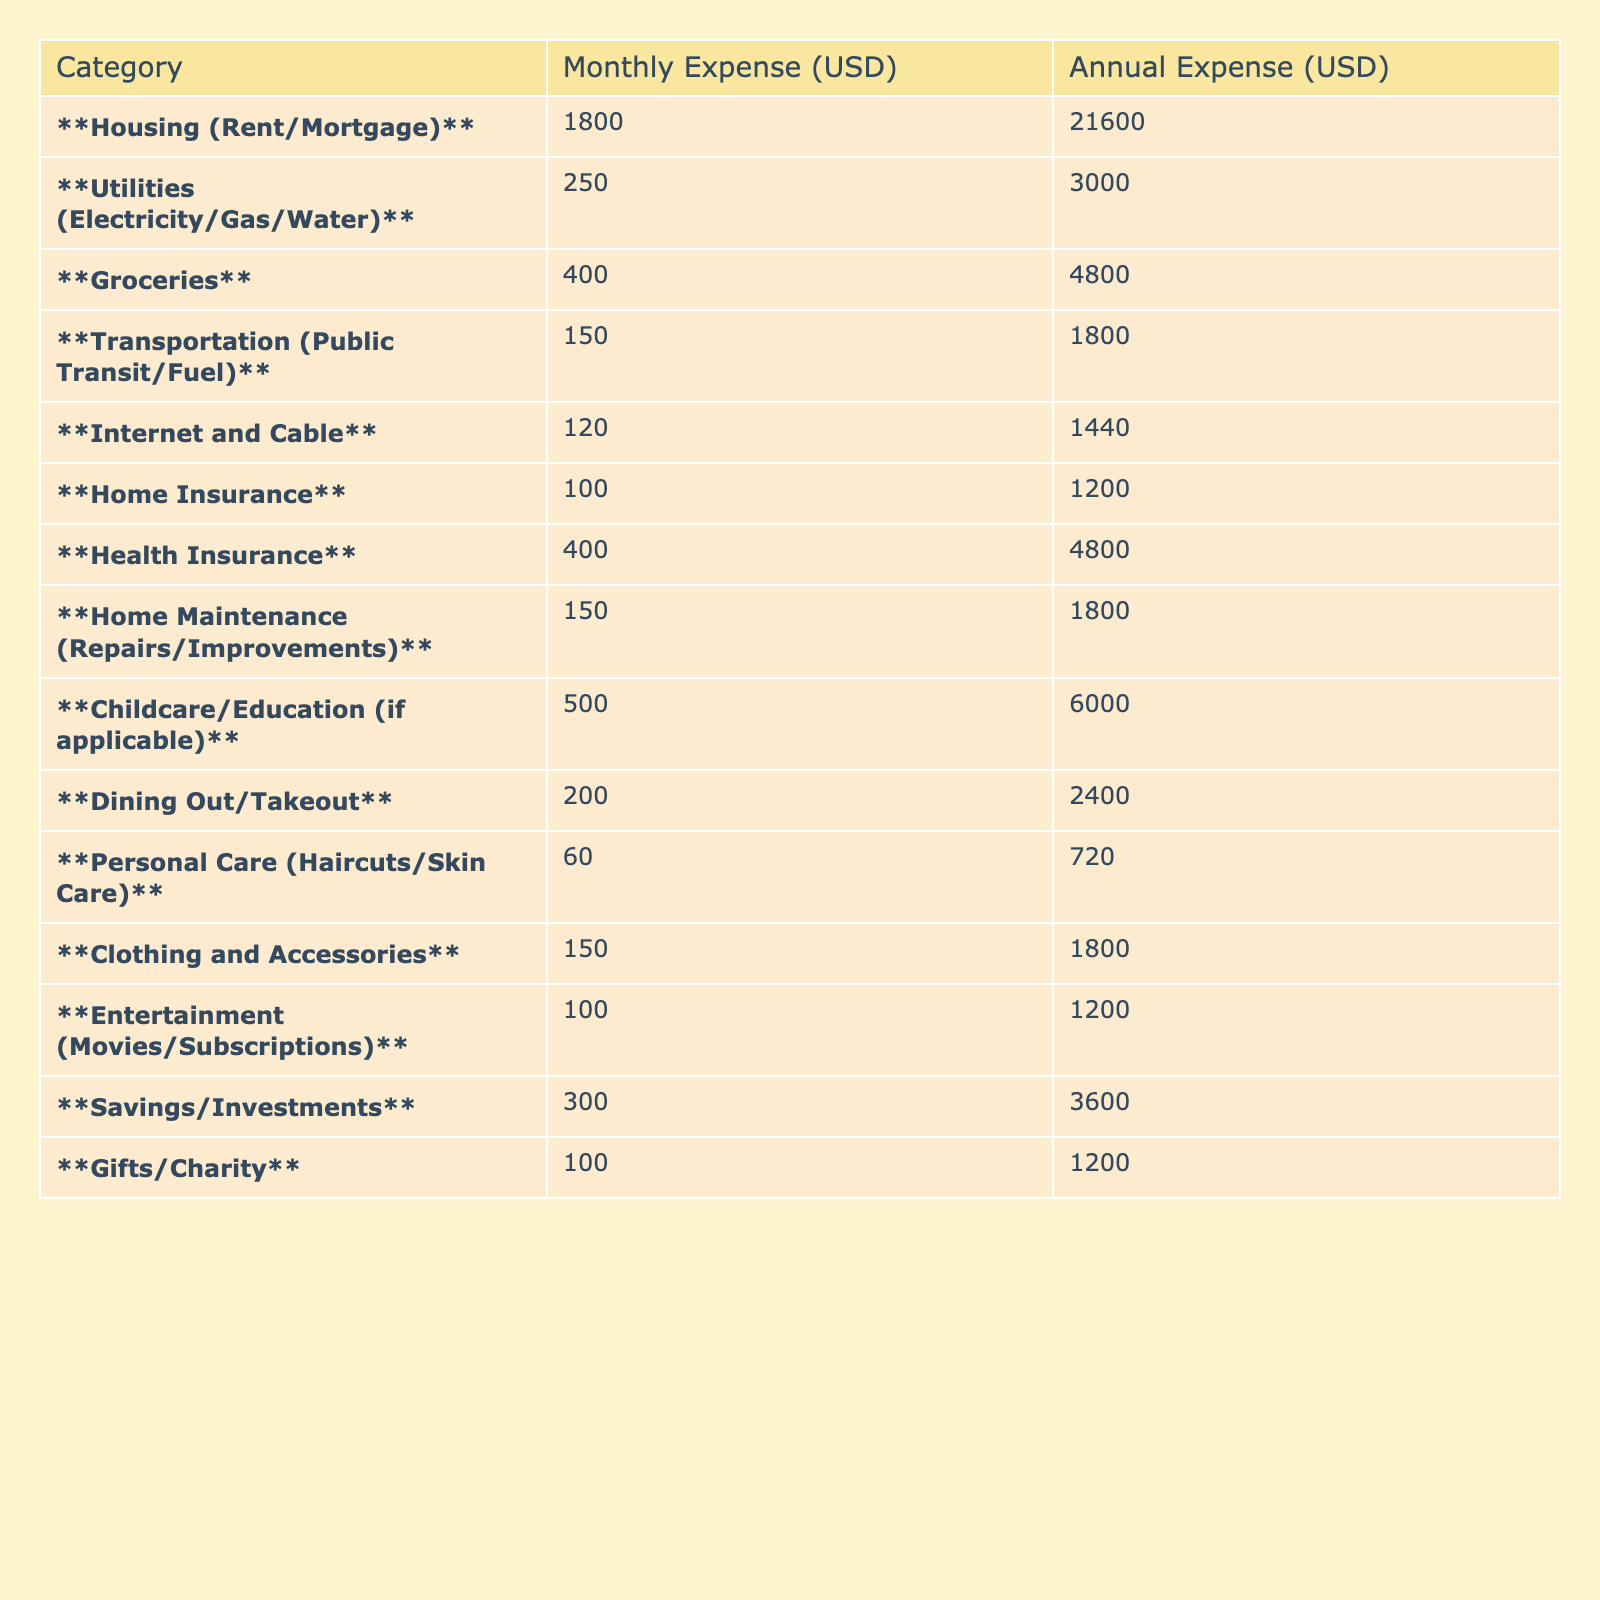What is the monthly expense for Housing? According to the table, the value in the "Monthly Expense (USD)" column for Housing (Rent/Mortgage) is **1800**.
Answer: 1800 How much do you spend annually on Groceries? The table shows that the "Annual Expense (USD)" for Groceries is **4800**.
Answer: 4800 What category has the highest monthly expense? By comparing all the monthly expenses, Housing (Rent/Mortgage) at **1800** is the highest.
Answer: Housing (Rent/Mortgage) What is the total monthly expense for Childcare/Education and Health Insurance? Adding the monthly expenses for both categories: **500** (Childcare/Education) + **400** (Health Insurance) = **900**.
Answer: 900 Do you spend more on Utilities or Personal Care? The monthly expense for Utilities is **250**, while for Personal Care it is **60**. Since **250** is greater than **60**, the spending on Utilities is higher.
Answer: Yes What is the average monthly expense across all categories? To find the average, sum all monthly expenses: **1800 + 250 + 400 + 150 + 120 + 100 + 400 + 150 + 500 + 200 + 60 + 150 + 100 + 300 + 100 = 3800**. There are 15 categories, so the average is **3800 / 15 = 253.33**.
Answer: 253.33 If you add up the annual expenses for Dining Out/Takeout and Entertainment, what is the total? Dining Out/Takeout has an annual expense of **2400**, and Entertainment has **1200**. Adding them: **2400 + 1200 = 3600**.
Answer: 3600 Is the total annual expense for Savings/Investments greater than that for Home Maintenance? The annual expense for Savings is **3600** and for Home Maintenance it is **1800**. Since **3600** is more than **1800**, the statement is true.
Answer: Yes What would be the total annual expense if you eliminated your Transportation costs? The annual expense for Transportation is **1800**. Subtract this from the total annual expenses (which is **36000**, calculated from the sum of all annual values) to get **36000 - 1800 = 34200**.
Answer: 34200 How does the monthly expense for Health Insurance compare to that of Internet and Cable? The monthly expense for Health Insurance is **400**, while for Internet and Cable it is **120**. Since **400** is greater than **120**, Health Insurance expenses are higher.
Answer: Yes 